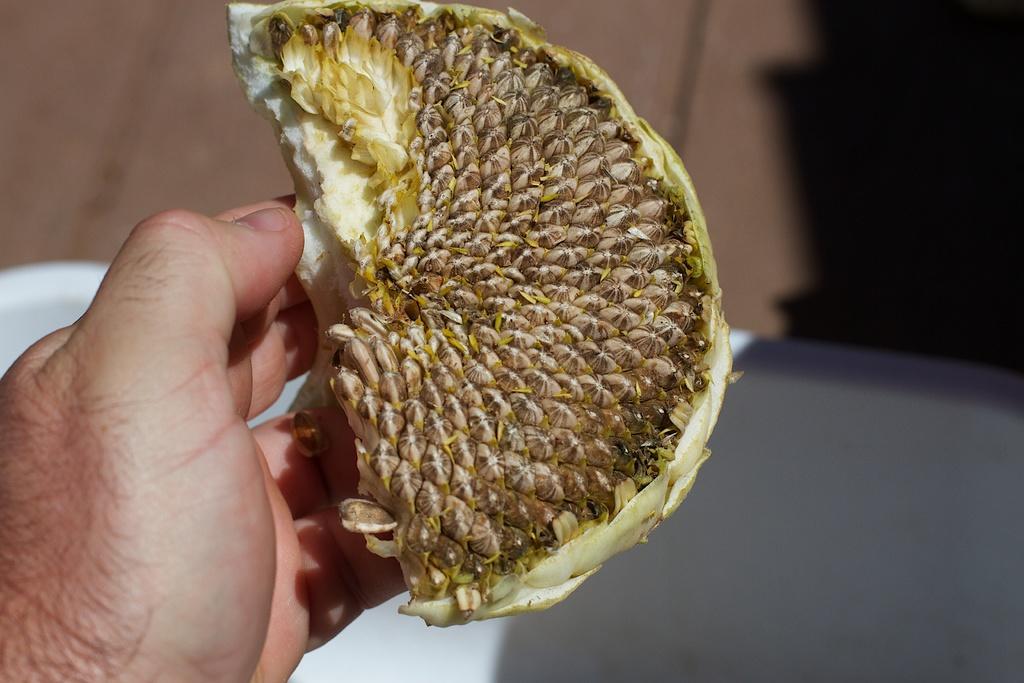Describe this image in one or two sentences. At the bottom left side of the image a person hand is there. A fruit is present in that hand. 